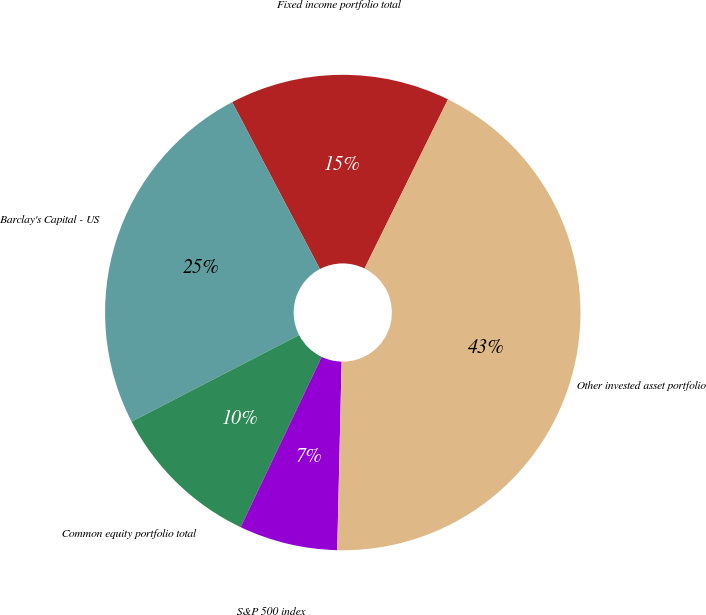Convert chart. <chart><loc_0><loc_0><loc_500><loc_500><pie_chart><fcel>Fixed income portfolio total<fcel>Barclay's Capital - US<fcel>Common equity portfolio total<fcel>S&P 500 index<fcel>Other invested asset portfolio<nl><fcel>15.0%<fcel>24.89%<fcel>10.34%<fcel>6.7%<fcel>43.08%<nl></chart> 